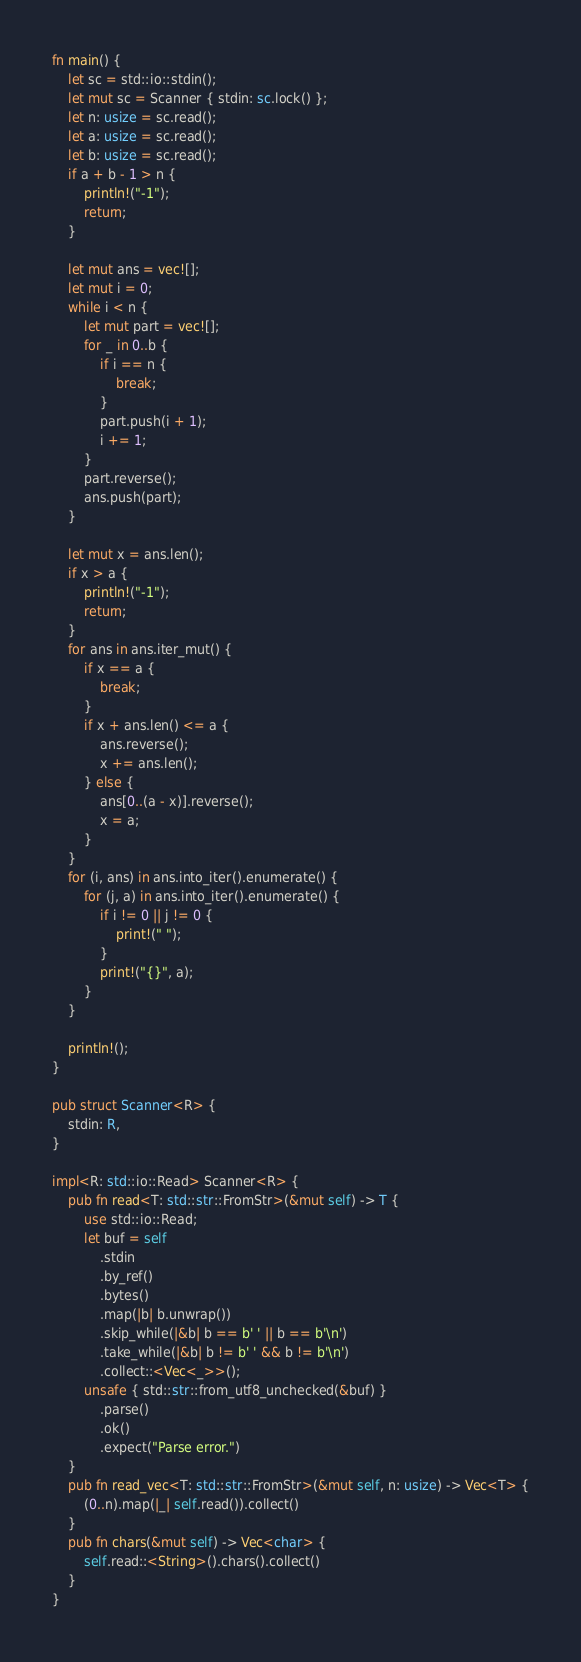Convert code to text. <code><loc_0><loc_0><loc_500><loc_500><_Rust_>fn main() {
    let sc = std::io::stdin();
    let mut sc = Scanner { stdin: sc.lock() };
    let n: usize = sc.read();
    let a: usize = sc.read();
    let b: usize = sc.read();
    if a + b - 1 > n {
        println!("-1");
        return;
    }

    let mut ans = vec![];
    let mut i = 0;
    while i < n {
        let mut part = vec![];
        for _ in 0..b {
            if i == n {
                break;
            }
            part.push(i + 1);
            i += 1;
        }
        part.reverse();
        ans.push(part);
    }

    let mut x = ans.len();
    if x > a {
        println!("-1");
        return;
    }
    for ans in ans.iter_mut() {
        if x == a {
            break;
        }
        if x + ans.len() <= a {
            ans.reverse();
            x += ans.len();
        } else {
            ans[0..(a - x)].reverse();
            x = a;
        }
    }
    for (i, ans) in ans.into_iter().enumerate() {
        for (j, a) in ans.into_iter().enumerate() {
            if i != 0 || j != 0 {
                print!(" ");
            }
            print!("{}", a);
        }
    }

    println!();
}

pub struct Scanner<R> {
    stdin: R,
}

impl<R: std::io::Read> Scanner<R> {
    pub fn read<T: std::str::FromStr>(&mut self) -> T {
        use std::io::Read;
        let buf = self
            .stdin
            .by_ref()
            .bytes()
            .map(|b| b.unwrap())
            .skip_while(|&b| b == b' ' || b == b'\n')
            .take_while(|&b| b != b' ' && b != b'\n')
            .collect::<Vec<_>>();
        unsafe { std::str::from_utf8_unchecked(&buf) }
            .parse()
            .ok()
            .expect("Parse error.")
    }
    pub fn read_vec<T: std::str::FromStr>(&mut self, n: usize) -> Vec<T> {
        (0..n).map(|_| self.read()).collect()
    }
    pub fn chars(&mut self) -> Vec<char> {
        self.read::<String>().chars().collect()
    }
}
</code> 